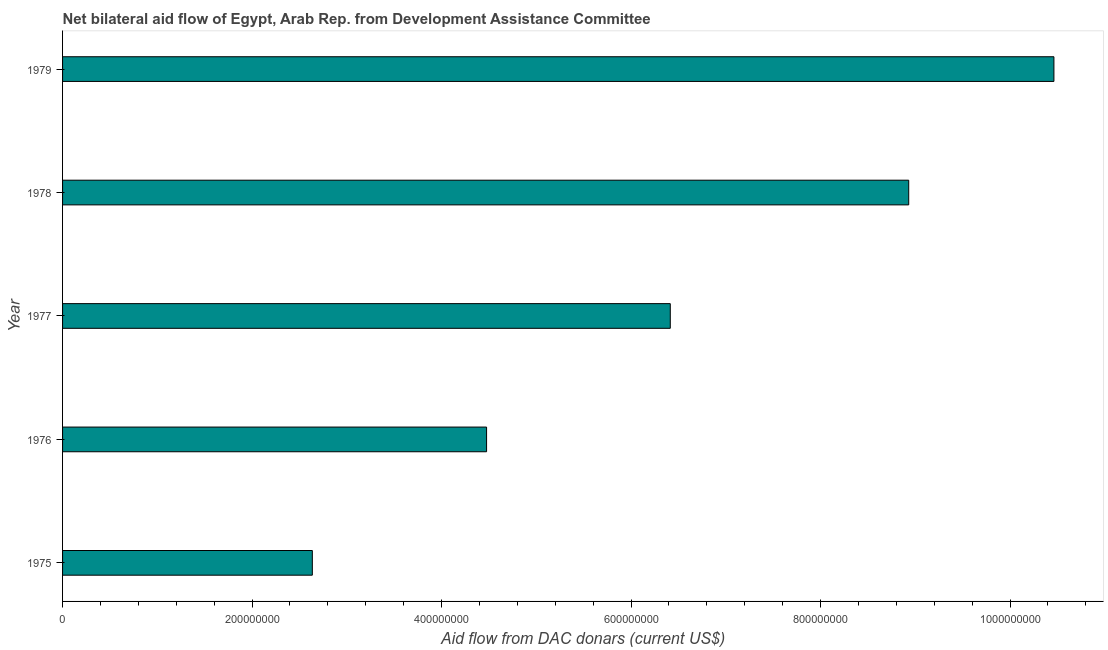What is the title of the graph?
Your response must be concise. Net bilateral aid flow of Egypt, Arab Rep. from Development Assistance Committee. What is the label or title of the X-axis?
Provide a short and direct response. Aid flow from DAC donars (current US$). What is the net bilateral aid flows from dac donors in 1979?
Provide a short and direct response. 1.05e+09. Across all years, what is the maximum net bilateral aid flows from dac donors?
Your answer should be very brief. 1.05e+09. Across all years, what is the minimum net bilateral aid flows from dac donors?
Keep it short and to the point. 2.64e+08. In which year was the net bilateral aid flows from dac donors maximum?
Your answer should be compact. 1979. In which year was the net bilateral aid flows from dac donors minimum?
Your answer should be very brief. 1975. What is the sum of the net bilateral aid flows from dac donors?
Offer a terse response. 3.29e+09. What is the difference between the net bilateral aid flows from dac donors in 1976 and 1979?
Make the answer very short. -5.99e+08. What is the average net bilateral aid flows from dac donors per year?
Offer a terse response. 6.58e+08. What is the median net bilateral aid flows from dac donors?
Offer a terse response. 6.41e+08. In how many years, is the net bilateral aid flows from dac donors greater than 800000000 US$?
Your answer should be compact. 2. Do a majority of the years between 1975 and 1978 (inclusive) have net bilateral aid flows from dac donors greater than 1000000000 US$?
Keep it short and to the point. No. What is the ratio of the net bilateral aid flows from dac donors in 1975 to that in 1978?
Give a very brief answer. 0.29. What is the difference between the highest and the second highest net bilateral aid flows from dac donors?
Your answer should be very brief. 1.53e+08. Is the sum of the net bilateral aid flows from dac donors in 1976 and 1979 greater than the maximum net bilateral aid flows from dac donors across all years?
Your answer should be compact. Yes. What is the difference between the highest and the lowest net bilateral aid flows from dac donors?
Offer a terse response. 7.83e+08. How many bars are there?
Provide a short and direct response. 5. How many years are there in the graph?
Offer a terse response. 5. Are the values on the major ticks of X-axis written in scientific E-notation?
Ensure brevity in your answer.  No. What is the Aid flow from DAC donars (current US$) of 1975?
Your answer should be very brief. 2.64e+08. What is the Aid flow from DAC donars (current US$) in 1976?
Provide a succinct answer. 4.48e+08. What is the Aid flow from DAC donars (current US$) of 1977?
Your answer should be very brief. 6.41e+08. What is the Aid flow from DAC donars (current US$) in 1978?
Make the answer very short. 8.93e+08. What is the Aid flow from DAC donars (current US$) of 1979?
Offer a terse response. 1.05e+09. What is the difference between the Aid flow from DAC donars (current US$) in 1975 and 1976?
Provide a succinct answer. -1.84e+08. What is the difference between the Aid flow from DAC donars (current US$) in 1975 and 1977?
Your answer should be very brief. -3.78e+08. What is the difference between the Aid flow from DAC donars (current US$) in 1975 and 1978?
Your answer should be compact. -6.29e+08. What is the difference between the Aid flow from DAC donars (current US$) in 1975 and 1979?
Keep it short and to the point. -7.83e+08. What is the difference between the Aid flow from DAC donars (current US$) in 1976 and 1977?
Give a very brief answer. -1.94e+08. What is the difference between the Aid flow from DAC donars (current US$) in 1976 and 1978?
Offer a terse response. -4.46e+08. What is the difference between the Aid flow from DAC donars (current US$) in 1976 and 1979?
Your response must be concise. -5.99e+08. What is the difference between the Aid flow from DAC donars (current US$) in 1977 and 1978?
Your answer should be very brief. -2.52e+08. What is the difference between the Aid flow from DAC donars (current US$) in 1977 and 1979?
Provide a short and direct response. -4.05e+08. What is the difference between the Aid flow from DAC donars (current US$) in 1978 and 1979?
Your answer should be very brief. -1.53e+08. What is the ratio of the Aid flow from DAC donars (current US$) in 1975 to that in 1976?
Ensure brevity in your answer.  0.59. What is the ratio of the Aid flow from DAC donars (current US$) in 1975 to that in 1977?
Your response must be concise. 0.41. What is the ratio of the Aid flow from DAC donars (current US$) in 1975 to that in 1978?
Keep it short and to the point. 0.29. What is the ratio of the Aid flow from DAC donars (current US$) in 1975 to that in 1979?
Offer a terse response. 0.25. What is the ratio of the Aid flow from DAC donars (current US$) in 1976 to that in 1977?
Offer a very short reply. 0.7. What is the ratio of the Aid flow from DAC donars (current US$) in 1976 to that in 1978?
Offer a very short reply. 0.5. What is the ratio of the Aid flow from DAC donars (current US$) in 1976 to that in 1979?
Your response must be concise. 0.43. What is the ratio of the Aid flow from DAC donars (current US$) in 1977 to that in 1978?
Provide a short and direct response. 0.72. What is the ratio of the Aid flow from DAC donars (current US$) in 1977 to that in 1979?
Your answer should be very brief. 0.61. What is the ratio of the Aid flow from DAC donars (current US$) in 1978 to that in 1979?
Offer a terse response. 0.85. 